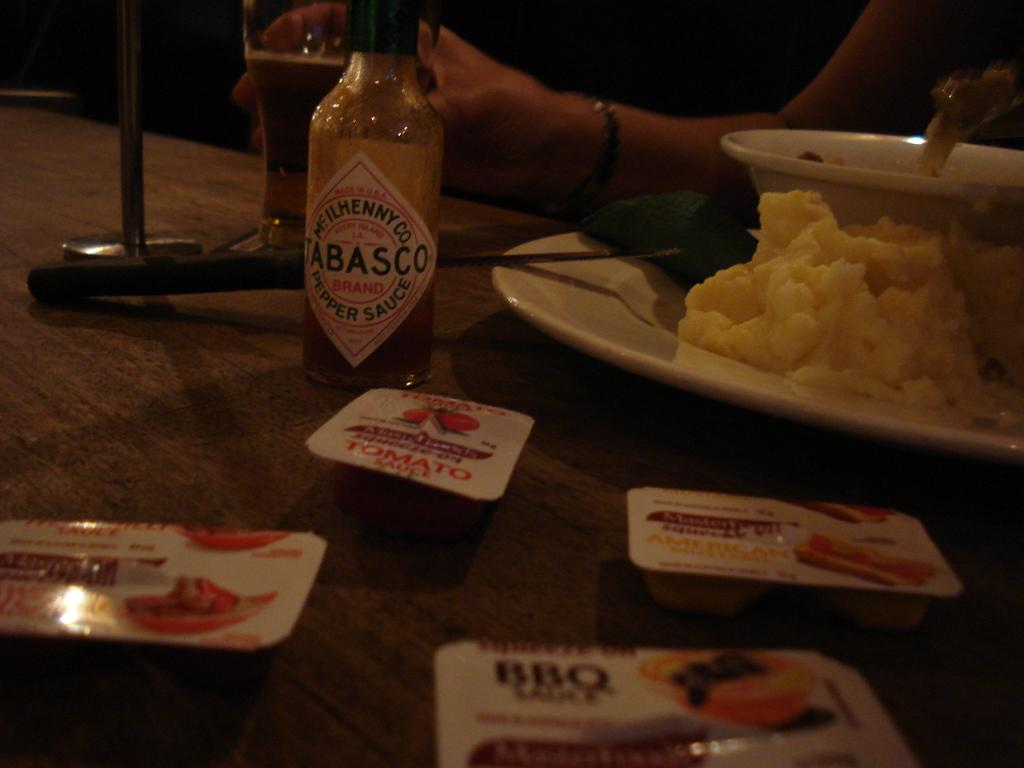What piece of furniture is in the image? There is a table in the image. What items can be seen on the table? A bottle, a glass, a plate, and a bowl are on the table. Are there any food items on the table? Yes, there are food items on the table. Who is in front of the table? There is a woman in front of the table. What is the woman holding? The woman is holding a glass. What direction is the suit facing on the table? There is no suit present on the table in the image. How many minutes does it take for the food to be ready in the image? The image does not provide information about the time it takes for the food to be ready. 